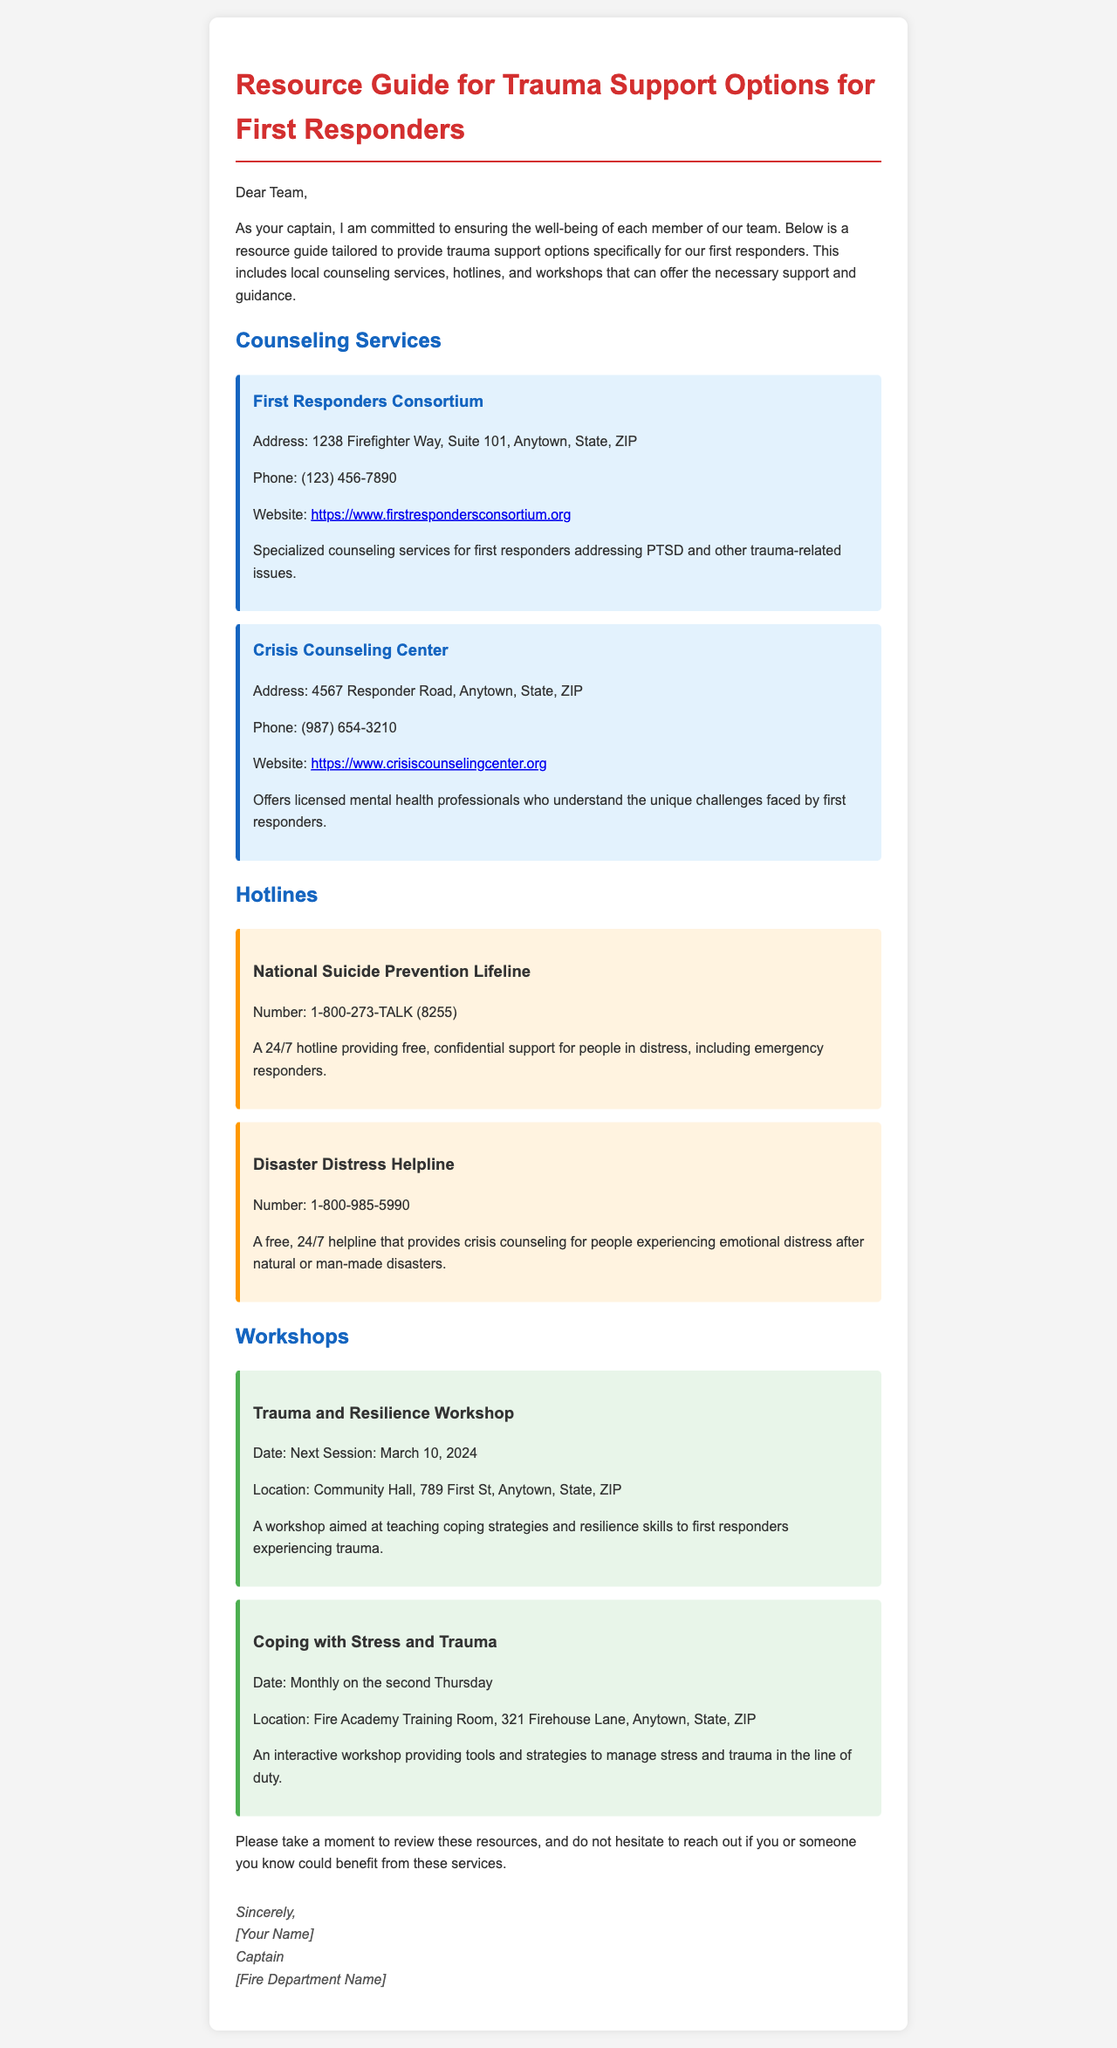What is the phone number for the First Responders Consortium? The phone number is listed in the resource section of the document under First Responders Consortium.
Answer: (123) 456-7890 What workshop is scheduled for March 10, 2024? The document mentions the "Trauma and Resilience Workshop" with that date.
Answer: Trauma and Resilience Workshop What is the address of the Crisis Counseling Center? The address is found in the resource section under Crisis Counseling Center.
Answer: 4567 Responder Road, Anytown, State, ZIP What is the purpose of the National Suicide Prevention Lifeline? The document states that it provides free, confidential support for people in distress, including emergency responders.
Answer: Support for people in distress How often does the "Coping with Stress and Trauma" workshop occur? The frequency of this workshop is mentioned in the workshops section of the document.
Answer: Monthly on the second Thursday What is the website for the First Responders Consortium? The website is listed under the contact information for First Responders Consortium in the document.
Answer: https://www.firstrespondersconsortium.org Who is the sender of the resource guide? The sender's name is included in the signature at the end of the document.
Answer: [Your Name] What type of document is this? The overall structure and content indicate that it is an informative email.
Answer: Email resource guide 